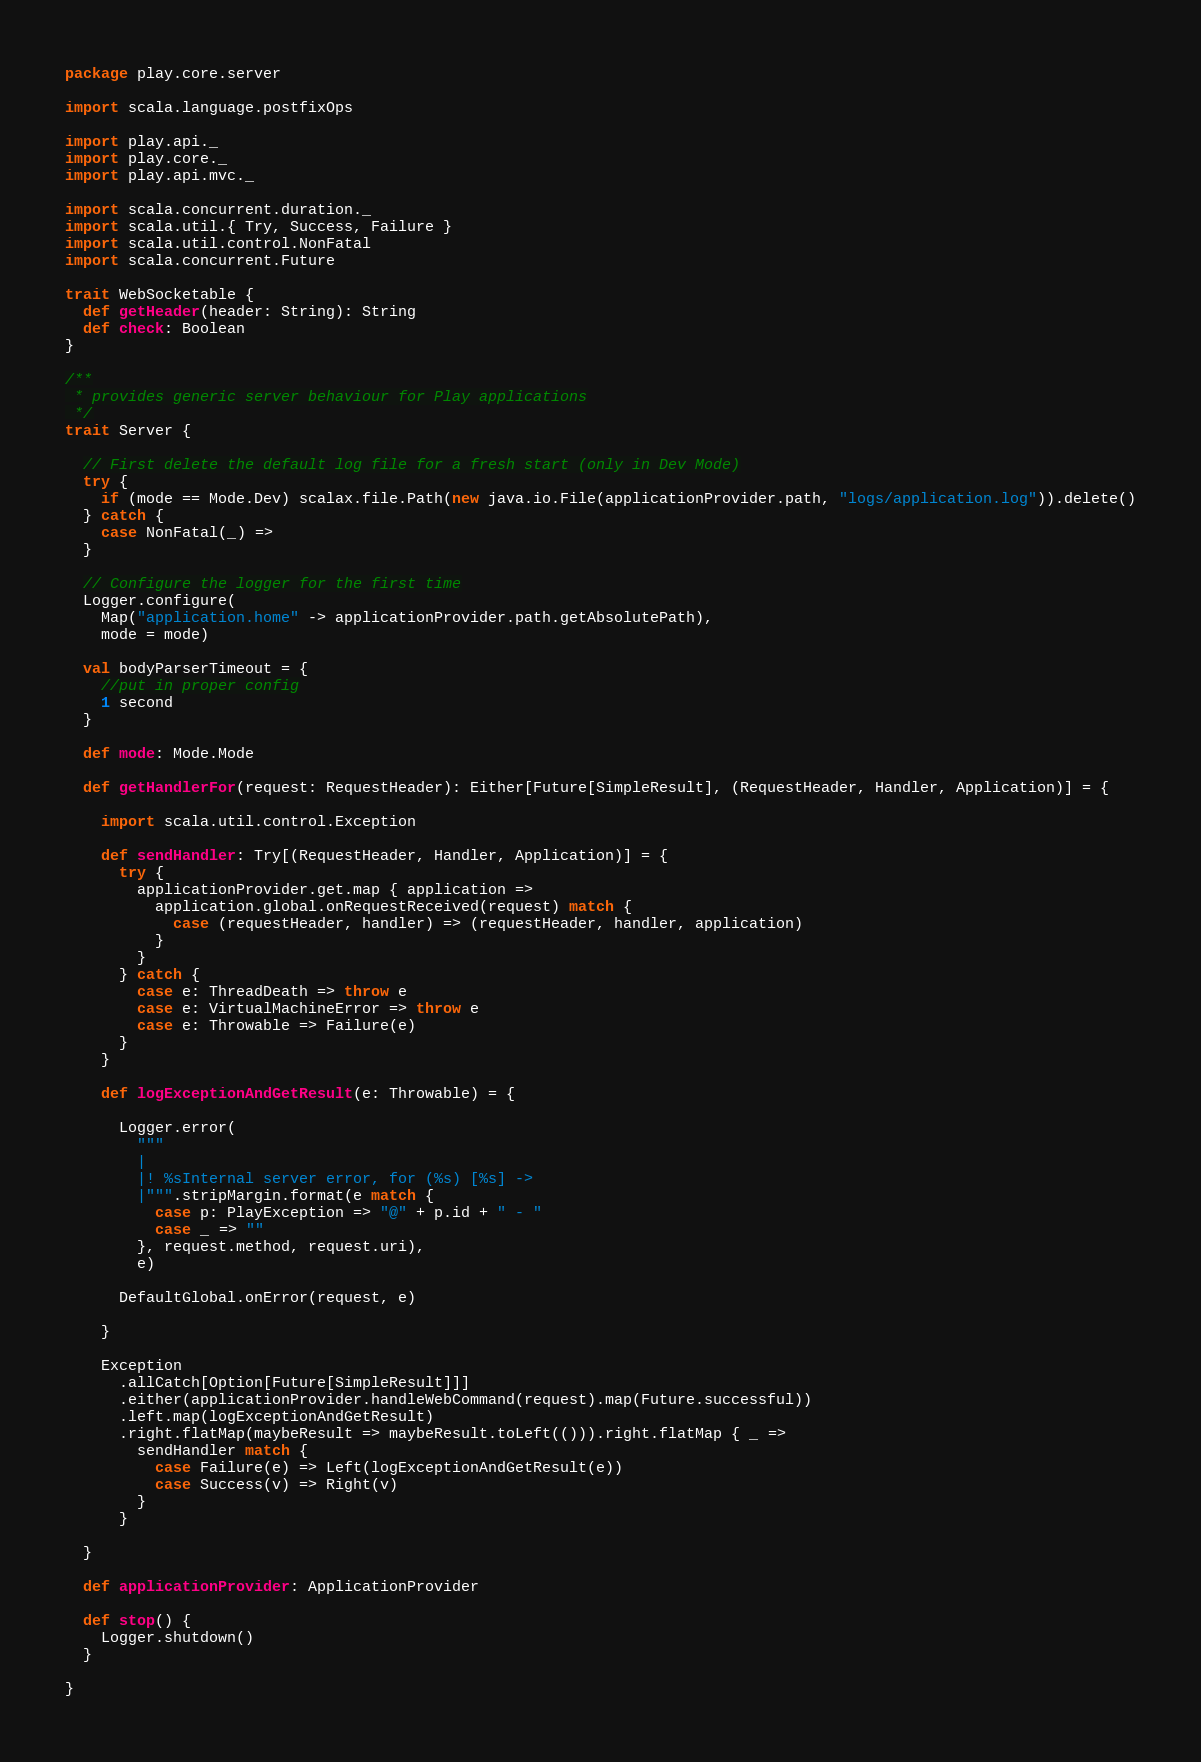Convert code to text. <code><loc_0><loc_0><loc_500><loc_500><_Scala_>package play.core.server

import scala.language.postfixOps

import play.api._
import play.core._
import play.api.mvc._

import scala.concurrent.duration._
import scala.util.{ Try, Success, Failure }
import scala.util.control.NonFatal
import scala.concurrent.Future

trait WebSocketable {
  def getHeader(header: String): String
  def check: Boolean
}

/**
 * provides generic server behaviour for Play applications
 */
trait Server {

  // First delete the default log file for a fresh start (only in Dev Mode)
  try {
    if (mode == Mode.Dev) scalax.file.Path(new java.io.File(applicationProvider.path, "logs/application.log")).delete()
  } catch {
    case NonFatal(_) =>
  }

  // Configure the logger for the first time
  Logger.configure(
    Map("application.home" -> applicationProvider.path.getAbsolutePath),
    mode = mode)

  val bodyParserTimeout = {
    //put in proper config
    1 second
  }

  def mode: Mode.Mode

  def getHandlerFor(request: RequestHeader): Either[Future[SimpleResult], (RequestHeader, Handler, Application)] = {

    import scala.util.control.Exception

    def sendHandler: Try[(RequestHeader, Handler, Application)] = {
      try {
        applicationProvider.get.map { application =>
          application.global.onRequestReceived(request) match {
            case (requestHeader, handler) => (requestHeader, handler, application)
          }
        }
      } catch {
        case e: ThreadDeath => throw e
        case e: VirtualMachineError => throw e
        case e: Throwable => Failure(e)
      }
    }

    def logExceptionAndGetResult(e: Throwable) = {

      Logger.error(
        """
        |
        |! %sInternal server error, for (%s) [%s] ->
        |""".stripMargin.format(e match {
          case p: PlayException => "@" + p.id + " - "
          case _ => ""
        }, request.method, request.uri),
        e)

      DefaultGlobal.onError(request, e)

    }

    Exception
      .allCatch[Option[Future[SimpleResult]]]
      .either(applicationProvider.handleWebCommand(request).map(Future.successful))
      .left.map(logExceptionAndGetResult)
      .right.flatMap(maybeResult => maybeResult.toLeft(())).right.flatMap { _ =>
        sendHandler match {
          case Failure(e) => Left(logExceptionAndGetResult(e))
          case Success(v) => Right(v)
        }
      }

  }

  def applicationProvider: ApplicationProvider

  def stop() {
    Logger.shutdown()
  }

}
</code> 